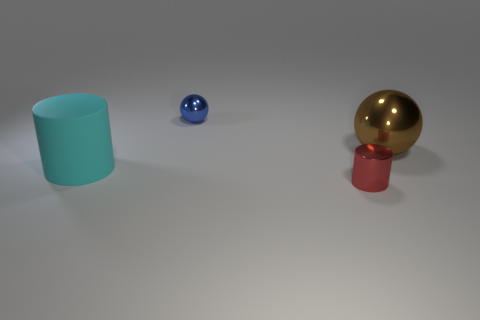How is the lighting affecting the appearance of the objects? The lighting in the image seems to be coming from above, casting soft shadows beneath the objects. It accentuates the reflective qualities of the shiny surfaces, like the gold ball, and provides a sense of depth and dimension to the scene. Is there any light source visible in the reflections? While we cannot see a direct light source within the reflections, the brightness and highlights on the objects suggest a diffuse overhead light, which may be out of the picture's frame. 